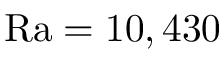Convert formula to latex. <formula><loc_0><loc_0><loc_500><loc_500>R a = 1 0 , 4 3 0</formula> 